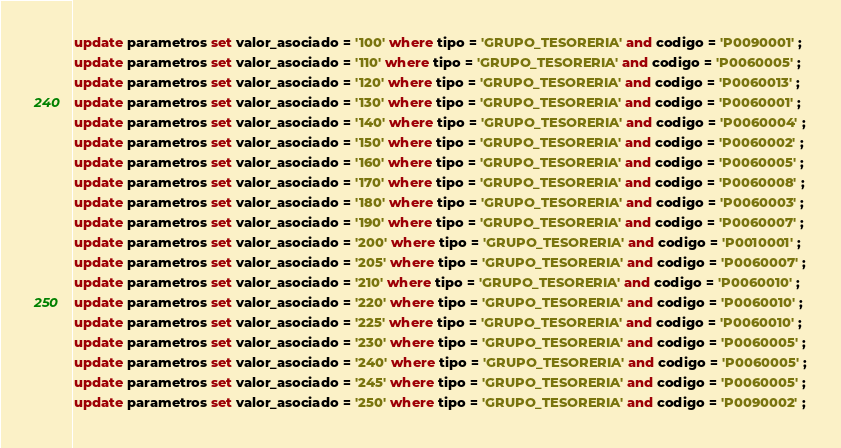Convert code to text. <code><loc_0><loc_0><loc_500><loc_500><_SQL_>update parametros set valor_asociado = '100' where tipo = 'GRUPO_TESORERIA' and codigo = 'P0090001' ;
update parametros set valor_asociado = '110' where tipo = 'GRUPO_TESORERIA' and codigo = 'P0060005' ;
update parametros set valor_asociado = '120' where tipo = 'GRUPO_TESORERIA' and codigo = 'P0060013' ;
update parametros set valor_asociado = '130' where tipo = 'GRUPO_TESORERIA' and codigo = 'P0060001' ;
update parametros set valor_asociado = '140' where tipo = 'GRUPO_TESORERIA' and codigo = 'P0060004' ;
update parametros set valor_asociado = '150' where tipo = 'GRUPO_TESORERIA' and codigo = 'P0060002' ;
update parametros set valor_asociado = '160' where tipo = 'GRUPO_TESORERIA' and codigo = 'P0060005' ;
update parametros set valor_asociado = '170' where tipo = 'GRUPO_TESORERIA' and codigo = 'P0060008' ;
update parametros set valor_asociado = '180' where tipo = 'GRUPO_TESORERIA' and codigo = 'P0060003' ;
update parametros set valor_asociado = '190' where tipo = 'GRUPO_TESORERIA' and codigo = 'P0060007' ;
update parametros set valor_asociado = '200' where tipo = 'GRUPO_TESORERIA' and codigo = 'P0010001' ;
update parametros set valor_asociado = '205' where tipo = 'GRUPO_TESORERIA' and codigo = 'P0060007' ;
update parametros set valor_asociado = '210' where tipo = 'GRUPO_TESORERIA' and codigo = 'P0060010' ;
update parametros set valor_asociado = '220' where tipo = 'GRUPO_TESORERIA' and codigo = 'P0060010' ;
update parametros set valor_asociado = '225' where tipo = 'GRUPO_TESORERIA' and codigo = 'P0060010' ;
update parametros set valor_asociado = '230' where tipo = 'GRUPO_TESORERIA' and codigo = 'P0060005' ;
update parametros set valor_asociado = '240' where tipo = 'GRUPO_TESORERIA' and codigo = 'P0060005' ;
update parametros set valor_asociado = '245' where tipo = 'GRUPO_TESORERIA' and codigo = 'P0060005' ;
update parametros set valor_asociado = '250' where tipo = 'GRUPO_TESORERIA' and codigo = 'P0090002' ;</code> 